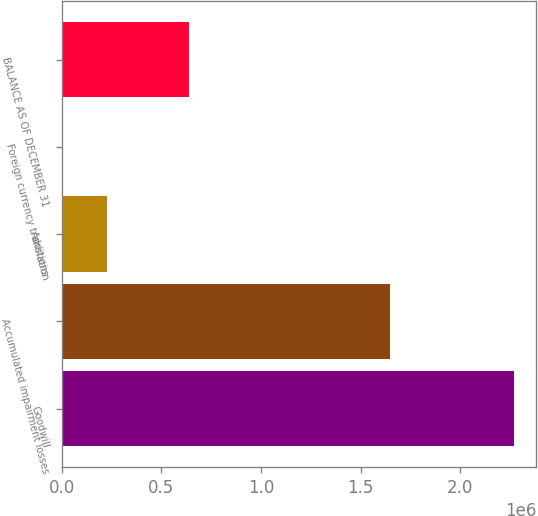<chart> <loc_0><loc_0><loc_500><loc_500><bar_chart><fcel>Goodwill<fcel>Accumulated impairment losses<fcel>Additions<fcel>Foreign currency translation<fcel>BALANCE AS OF DECEMBER 31<nl><fcel>2.2701e+06<fcel>1.65032e+06<fcel>227271<fcel>290<fcel>639097<nl></chart> 